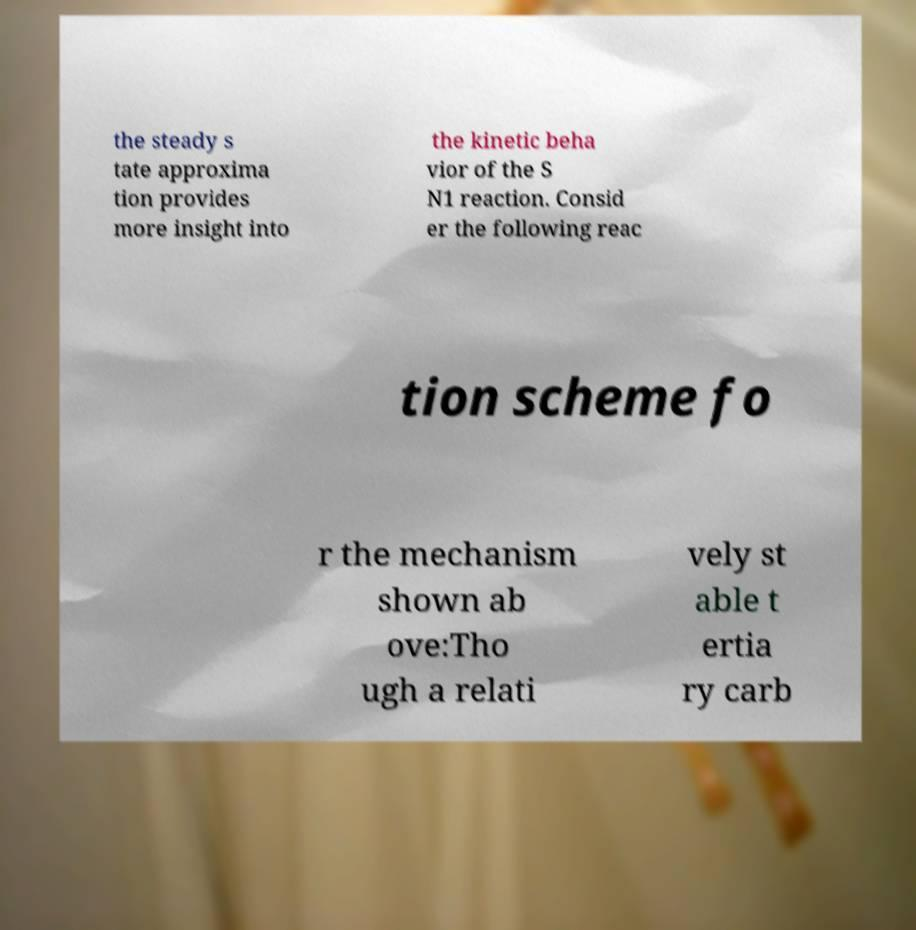Could you assist in decoding the text presented in this image and type it out clearly? the steady s tate approxima tion provides more insight into the kinetic beha vior of the S N1 reaction. Consid er the following reac tion scheme fo r the mechanism shown ab ove:Tho ugh a relati vely st able t ertia ry carb 